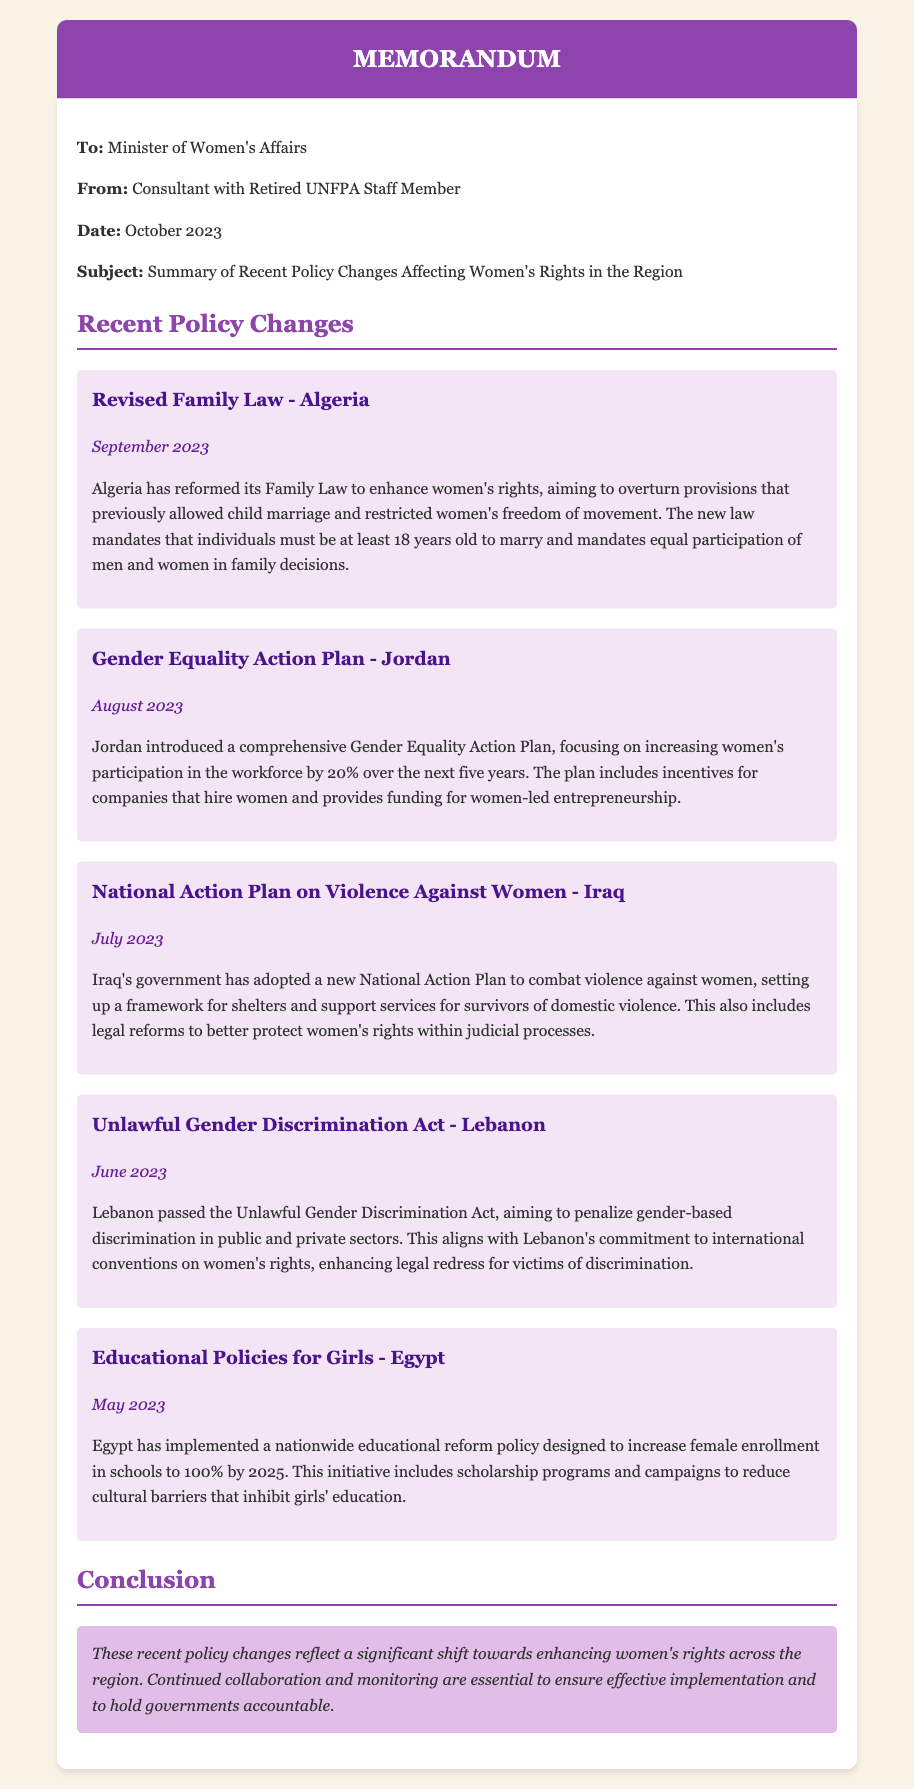what is the title of the memo? The title of the memo, as stated in the document, is "Summary of Recent Policy Changes Affecting Women's Rights in the Region."
Answer: Summary of Recent Policy Changes Affecting Women's Rights in the Region who is the author of the memo? The author of the memo is mentioned at the beginning as "Consultant with Retired UNFPA Staff Member."
Answer: Consultant with Retired UNFPA Staff Member which country revised its Family Law in September 2023? The memo specifies that Algeria revised its Family Law in September 2023.
Answer: Algeria what is the aim of Jordan's Gender Equality Action Plan? The aim of Jordan's Gender Equality Action Plan is to increase women's participation in the workforce by 20% over the next five years.
Answer: increase women's participation in the workforce by 20% how many policy changes are mentioned in the document? The document mentions a total of five recent policy changes affecting women's rights.
Answer: five what type of support does Iraq's National Action Plan on Violence Against Women include? The National Action Plan on Violence Against Women in Iraq includes a framework for shelters and support services for survivors of domestic violence.
Answer: shelters and support services for survivors of domestic violence what was a key component of Egypt's educational reform policy? A key component of Egypt's educational reform policy is to increase female enrollment in schools to 100% by 2025.
Answer: increase female enrollment in schools to 100% by 2025 why was the Unlawful Gender Discrimination Act passed in Lebanon? The Unlawful Gender Discrimination Act was passed to penalize gender-based discrimination in public and private sectors.
Answer: penalize gender-based discrimination in public and private sectors what is the conclusion highlighted in the memo? The conclusion emphasizes the need for continued collaboration and monitoring to ensure effective implementation of the policy changes.
Answer: Continued collaboration and monitoring are essential to ensure effective implementation 